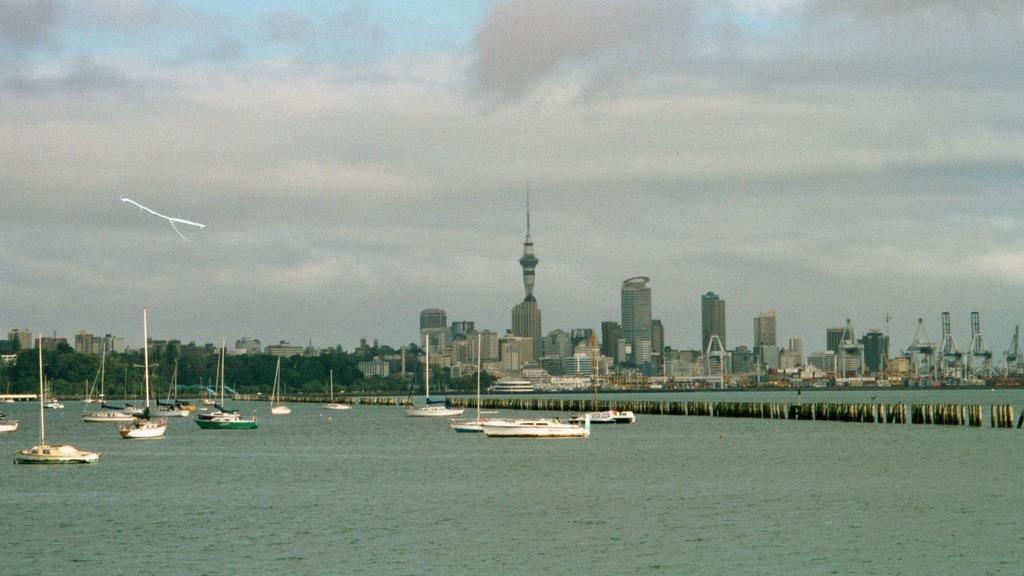Describe this image in one or two sentences. In this image at the bottom there is a river, in that river there are some boats and in the center there is a bridge. In the background there are some trees, buildings and skyscrapers and at the top of the image there is sky. 